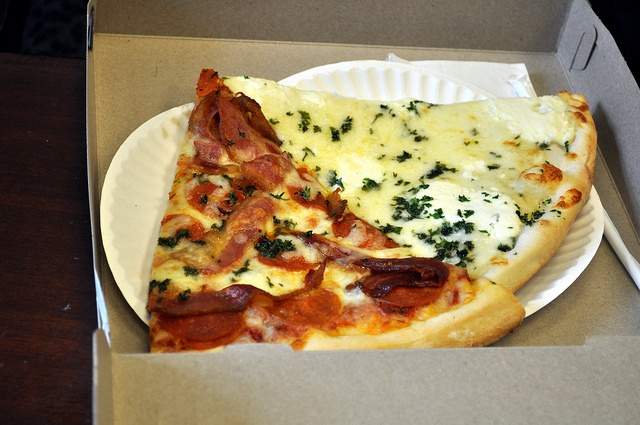Describe the objects in this image and their specific colors. I can see a pizza in black, khaki, brown, maroon, and tan tones in this image. 